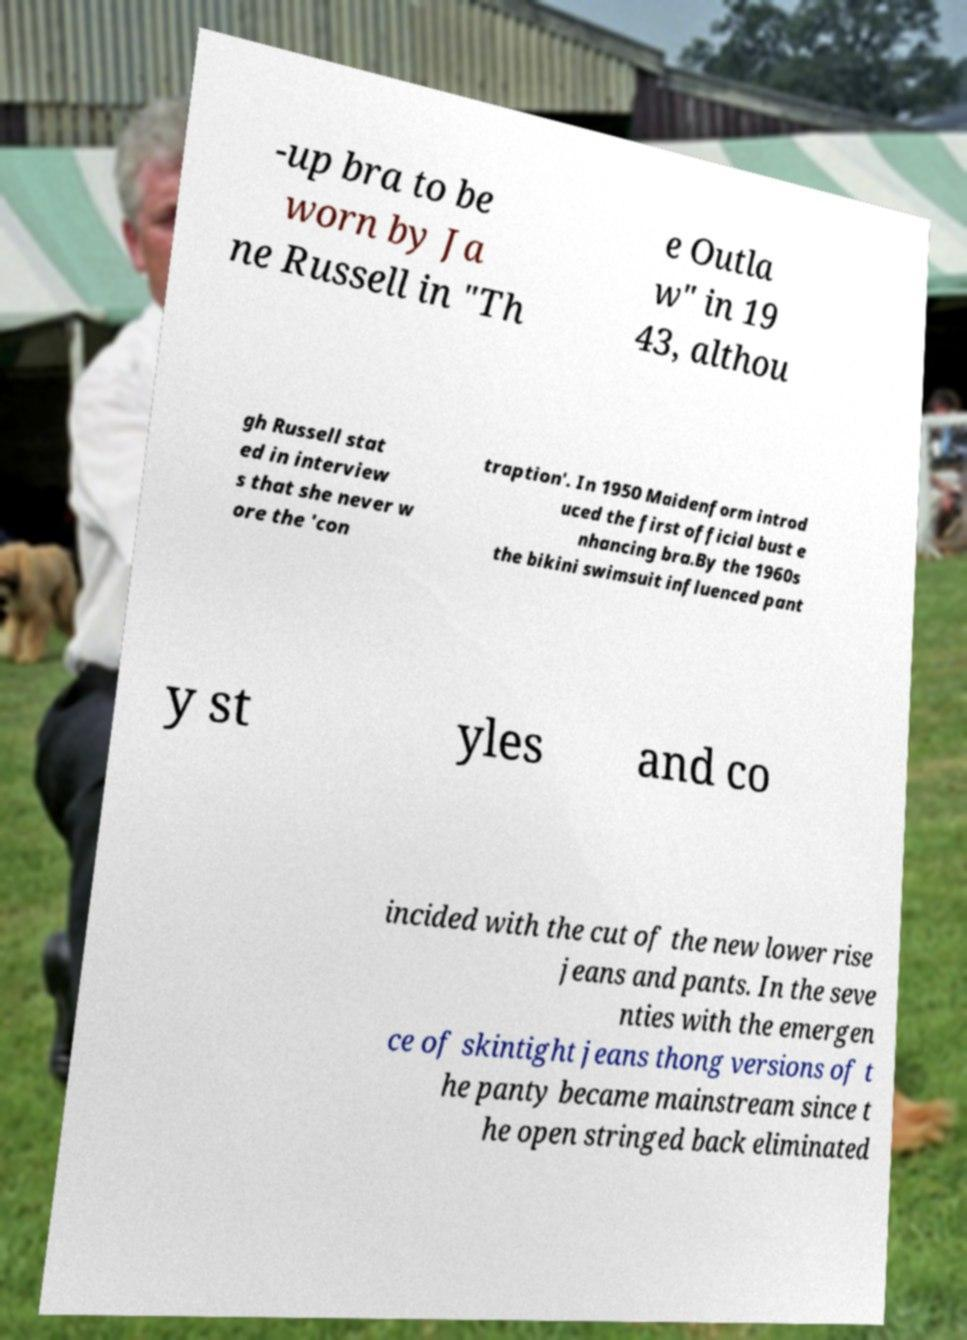Could you assist in decoding the text presented in this image and type it out clearly? -up bra to be worn by Ja ne Russell in "Th e Outla w" in 19 43, althou gh Russell stat ed in interview s that she never w ore the 'con traption'. In 1950 Maidenform introd uced the first official bust e nhancing bra.By the 1960s the bikini swimsuit influenced pant y st yles and co incided with the cut of the new lower rise jeans and pants. In the seve nties with the emergen ce of skintight jeans thong versions of t he panty became mainstream since t he open stringed back eliminated 